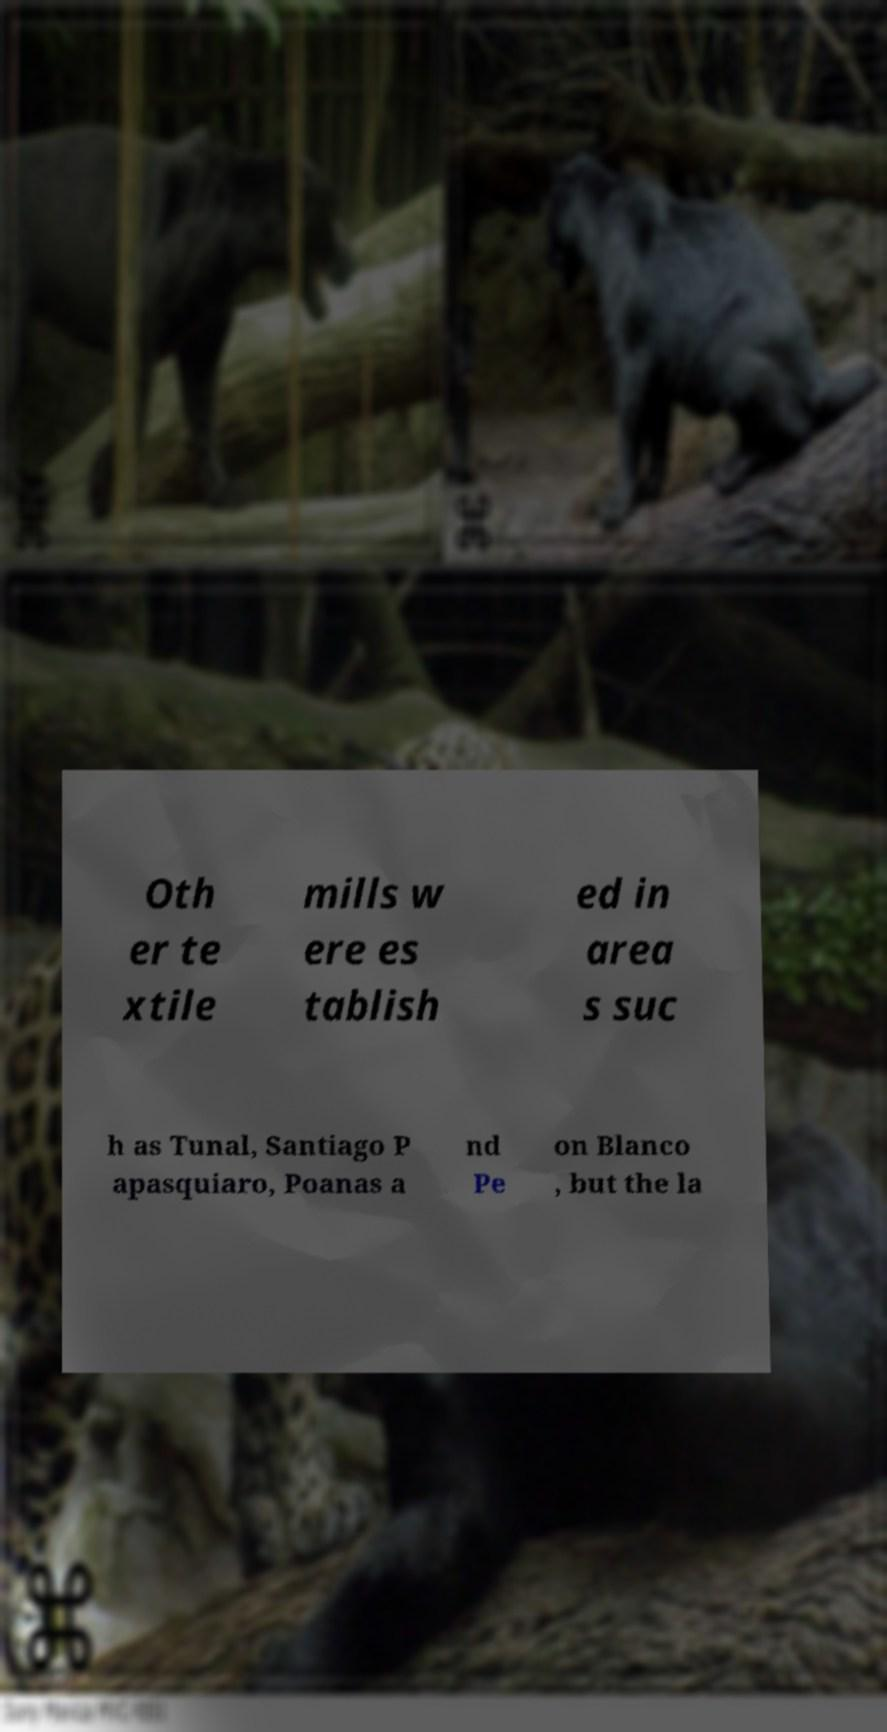Can you accurately transcribe the text from the provided image for me? Oth er te xtile mills w ere es tablish ed in area s suc h as Tunal, Santiago P apasquiaro, Poanas a nd Pe on Blanco , but the la 